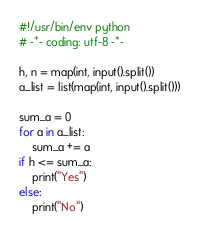<code> <loc_0><loc_0><loc_500><loc_500><_Python_>#!/usr/bin/env python
# -*- coding: utf-8 -*-

h, n = map(int, input().split())
a_list = list(map(int, input().split()))

sum_a = 0
for a in a_list:
    sum_a += a
if h <= sum_a:
    print("Yes")
else:
    print("No")</code> 